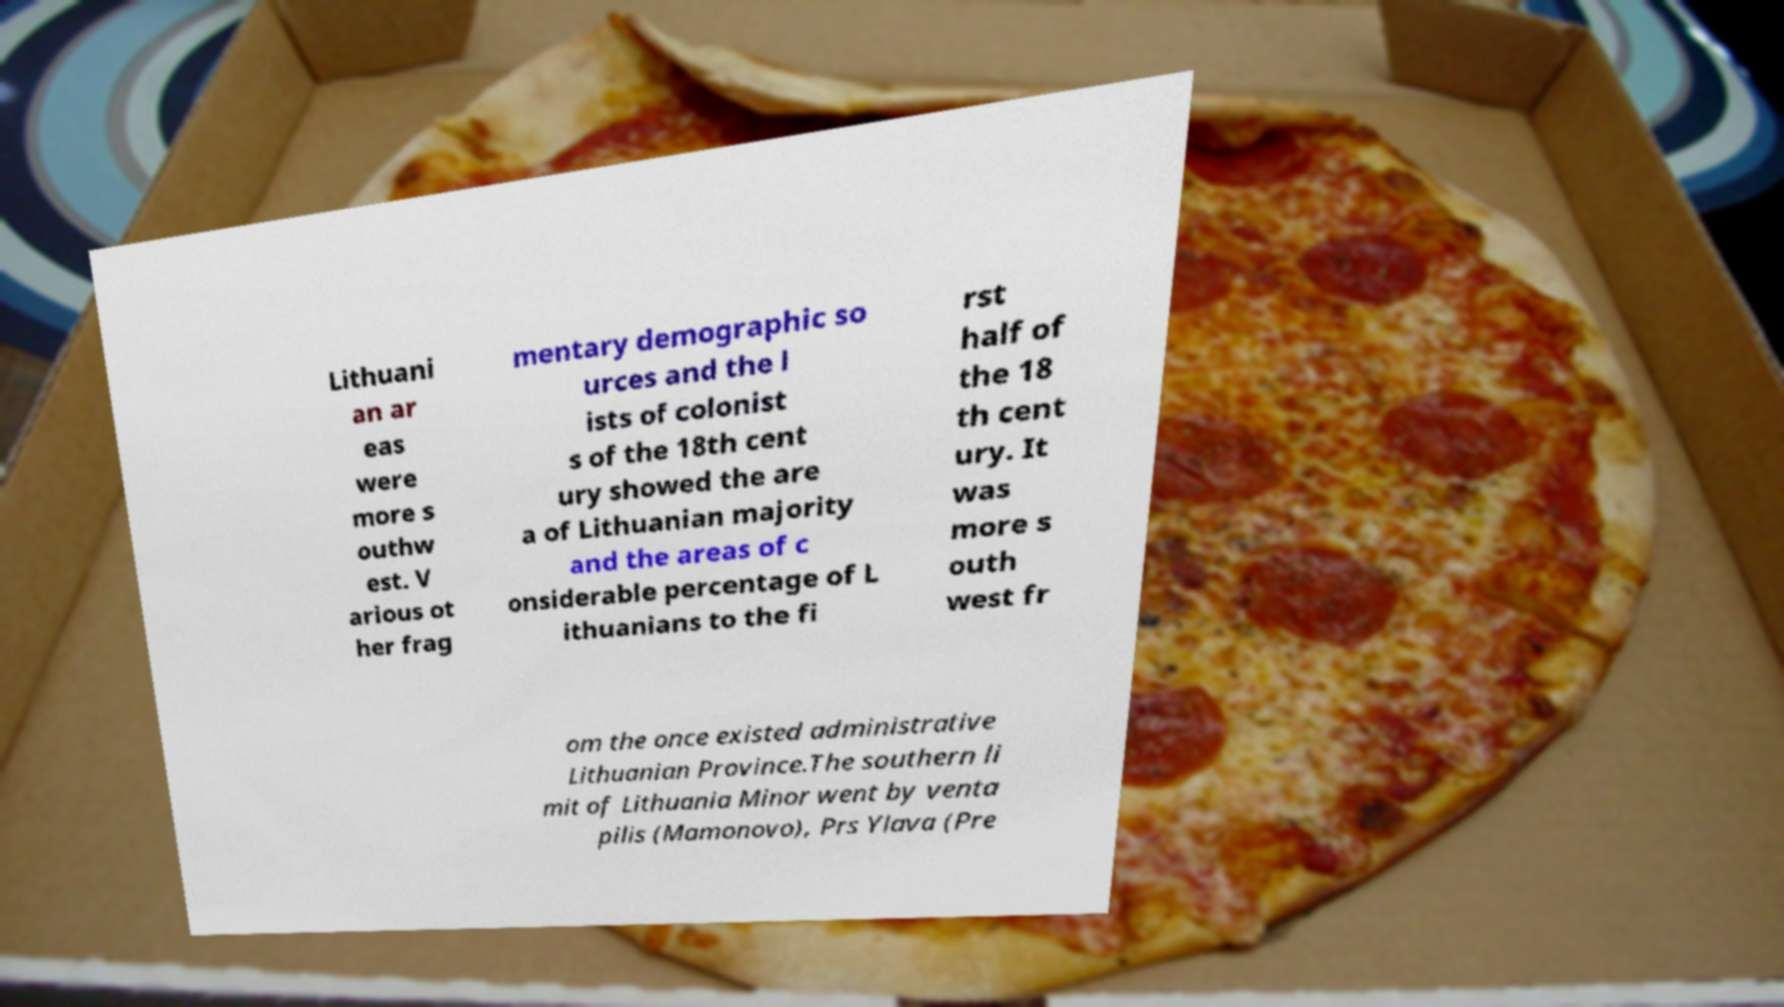Can you accurately transcribe the text from the provided image for me? Lithuani an ar eas were more s outhw est. V arious ot her frag mentary demographic so urces and the l ists of colonist s of the 18th cent ury showed the are a of Lithuanian majority and the areas of c onsiderable percentage of L ithuanians to the fi rst half of the 18 th cent ury. It was more s outh west fr om the once existed administrative Lithuanian Province.The southern li mit of Lithuania Minor went by venta pilis (Mamonovo), Prs Ylava (Pre 